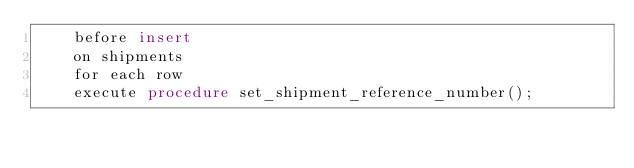<code> <loc_0><loc_0><loc_500><loc_500><_SQL_>    before insert
    on shipments
    for each row
    execute procedure set_shipment_reference_number();
</code> 